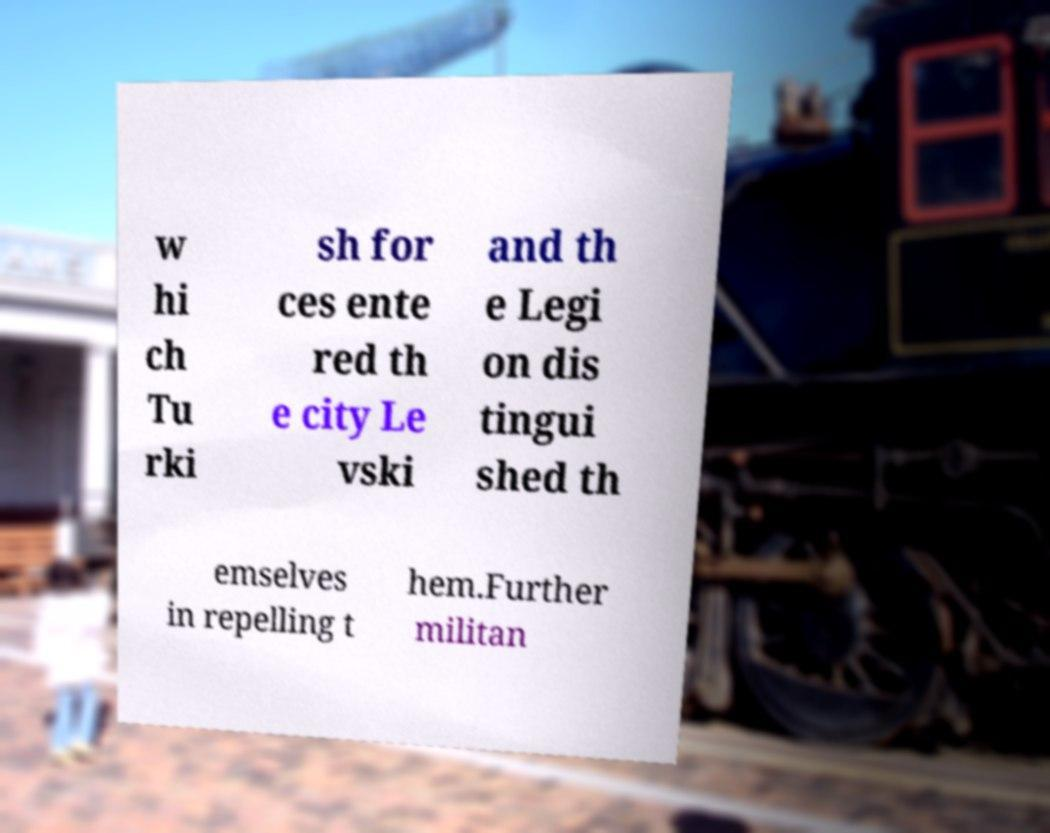Could you extract and type out the text from this image? w hi ch Tu rki sh for ces ente red th e city Le vski and th e Legi on dis tingui shed th emselves in repelling t hem.Further militan 